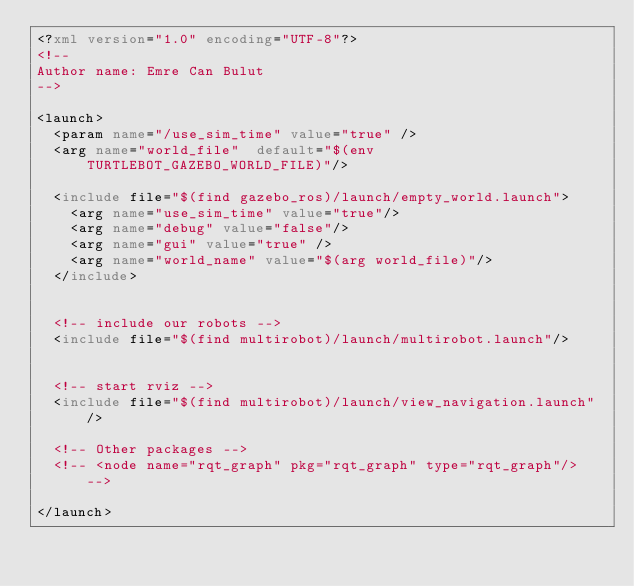<code> <loc_0><loc_0><loc_500><loc_500><_XML_><?xml version="1.0" encoding="UTF-8"?>
<!-- 
Author name: Emre Can Bulut
-->

<launch>
  <param name="/use_sim_time" value="true" />
  <arg name="world_file"  default="$(env TURTLEBOT_GAZEBO_WORLD_FILE)"/>

  <include file="$(find gazebo_ros)/launch/empty_world.launch">
    <arg name="use_sim_time" value="true"/>
    <arg name="debug" value="false"/>
    <arg name="gui" value="true" />
    <arg name="world_name" value="$(arg world_file)"/>
  </include>


  <!-- include our robots -->
  <include file="$(find multirobot)/launch/multirobot.launch"/>


  <!-- start rviz -->
  <include file="$(find multirobot)/launch/view_navigation.launch"/>

  <!-- Other packages -->
  <!-- <node name="rqt_graph" pkg="rqt_graph" type="rqt_graph"/> -->

</launch>
</code> 